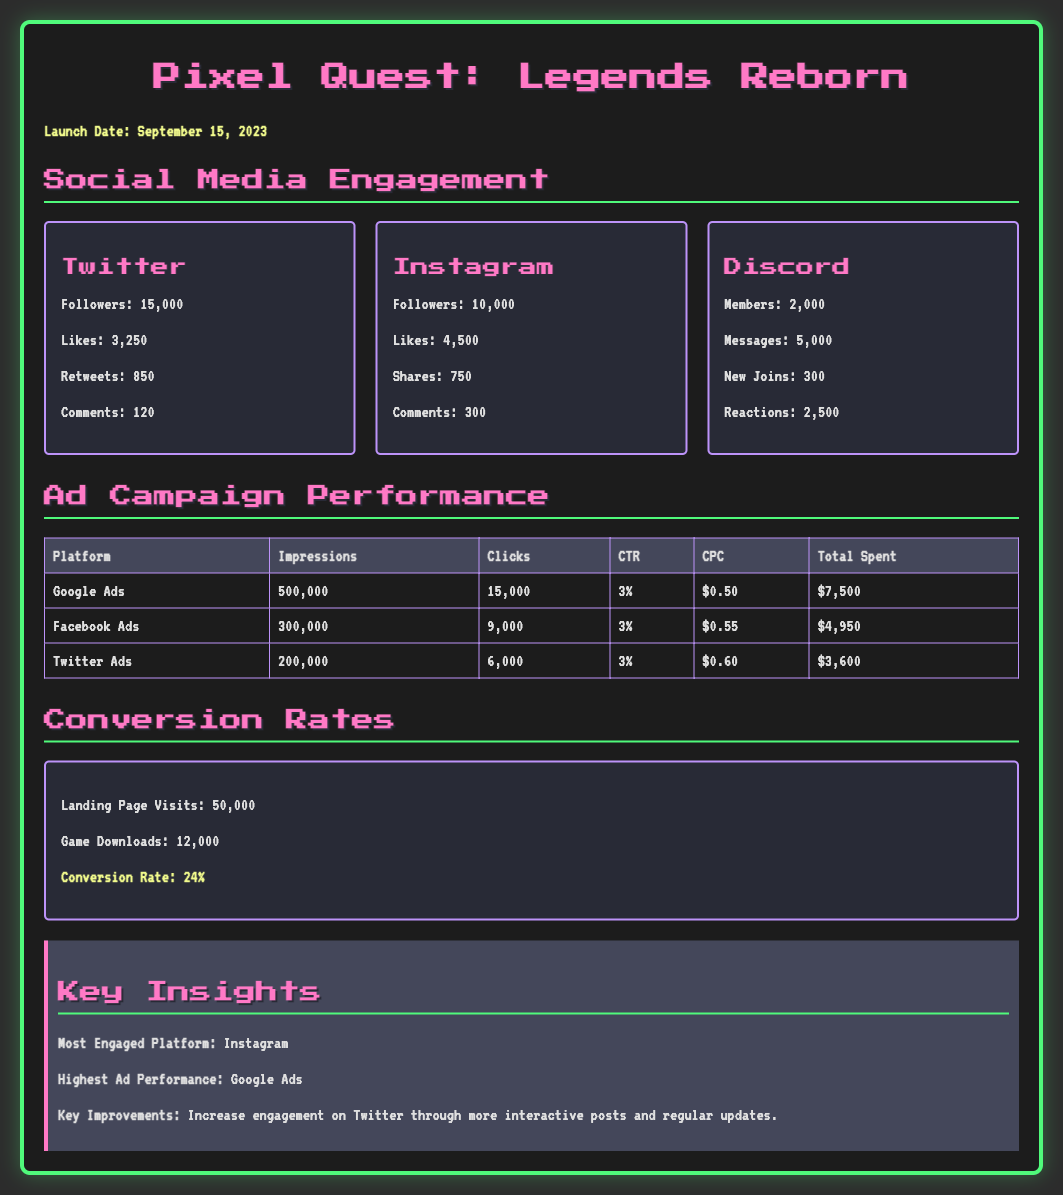What is the launch date of the game? The launch date is clearly stated in the document under the highlight section.
Answer: September 15, 2023 How many followers does the Twitter account have? The Twitter section lists the number of followers directly.
Answer: 15,000 Which platform had the highest total spent in ads? By comparing the 'Total Spent' from the Ad Campaign Performance table, the highest can be determined.
Answer: Google Ads What is the conversion rate for the game downloads? The conversion rate is explicitly stated in the Conversion Rates section.
Answer: 24% Which social media platform had the most likes? Likes for each social media platform are provided, and Instagram has the highest.
Answer: Instagram 